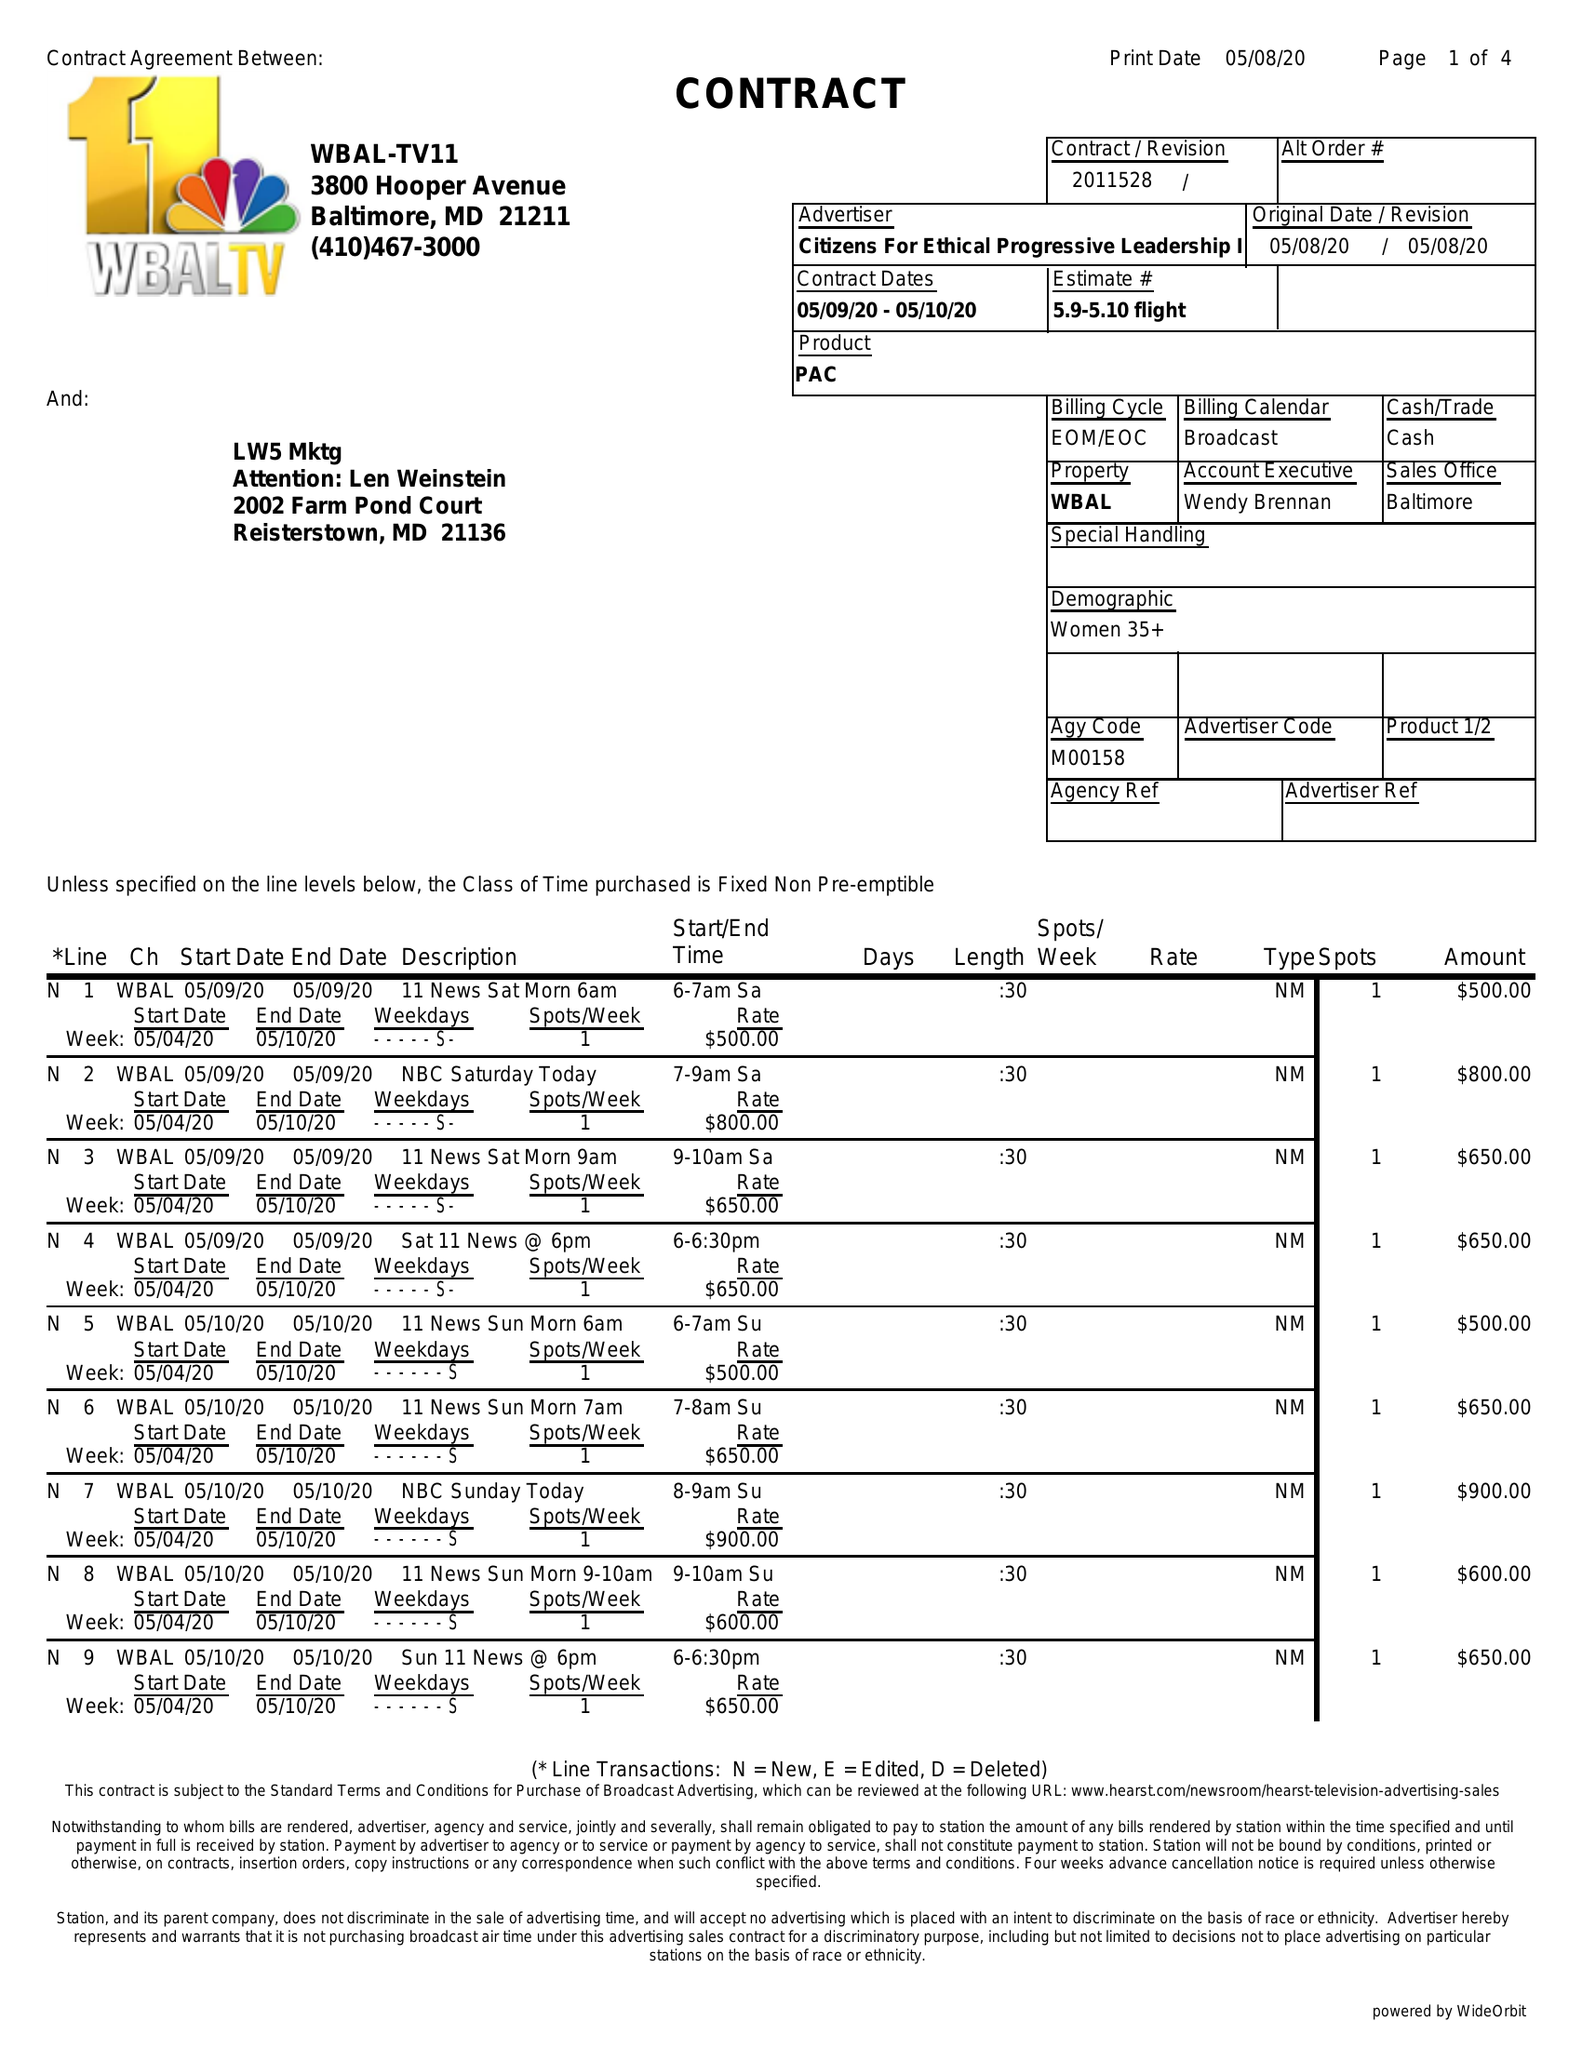What is the value for the flight_to?
Answer the question using a single word or phrase. 05/10/20 